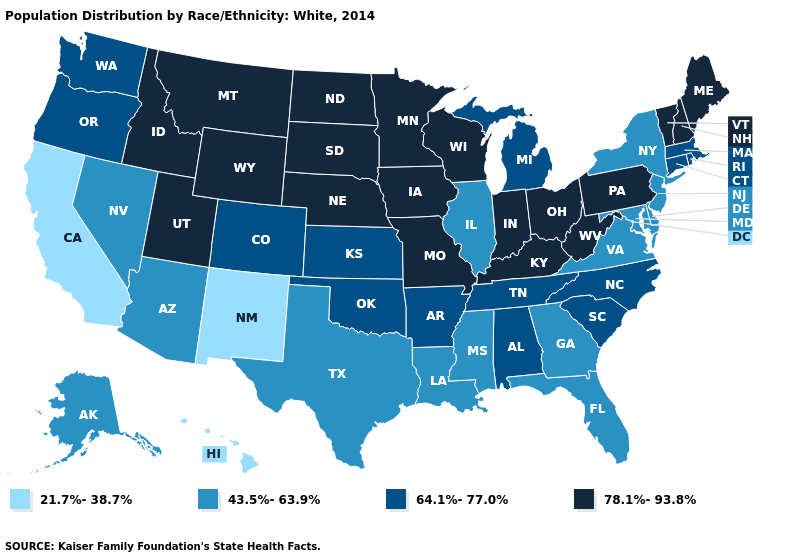What is the highest value in the USA?
Short answer required. 78.1%-93.8%. Which states have the lowest value in the USA?
Write a very short answer. California, Hawaii, New Mexico. Does Wyoming have the highest value in the West?
Be succinct. Yes. Which states have the lowest value in the Northeast?
Write a very short answer. New Jersey, New York. Among the states that border Indiana , does Illinois have the highest value?
Write a very short answer. No. What is the highest value in states that border California?
Give a very brief answer. 64.1%-77.0%. What is the value of Colorado?
Short answer required. 64.1%-77.0%. What is the value of Ohio?
Answer briefly. 78.1%-93.8%. What is the lowest value in states that border Kansas?
Answer briefly. 64.1%-77.0%. What is the value of Wyoming?
Concise answer only. 78.1%-93.8%. Does Illinois have a higher value than South Carolina?
Answer briefly. No. Name the states that have a value in the range 64.1%-77.0%?
Quick response, please. Alabama, Arkansas, Colorado, Connecticut, Kansas, Massachusetts, Michigan, North Carolina, Oklahoma, Oregon, Rhode Island, South Carolina, Tennessee, Washington. Is the legend a continuous bar?
Keep it brief. No. Name the states that have a value in the range 64.1%-77.0%?
Keep it brief. Alabama, Arkansas, Colorado, Connecticut, Kansas, Massachusetts, Michigan, North Carolina, Oklahoma, Oregon, Rhode Island, South Carolina, Tennessee, Washington. Which states have the highest value in the USA?
Keep it brief. Idaho, Indiana, Iowa, Kentucky, Maine, Minnesota, Missouri, Montana, Nebraska, New Hampshire, North Dakota, Ohio, Pennsylvania, South Dakota, Utah, Vermont, West Virginia, Wisconsin, Wyoming. 